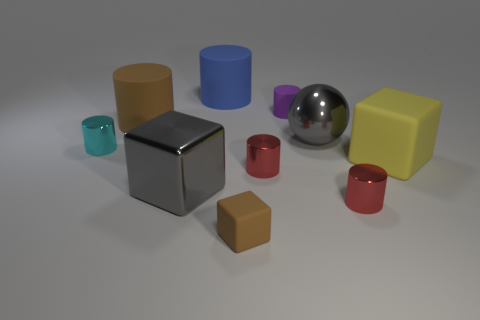How many metal things are tiny cyan things or gray spheres?
Ensure brevity in your answer.  2. Are there any big shiny things behind the gray object that is in front of the yellow object?
Provide a succinct answer. Yes. Is the large thing that is in front of the large yellow object made of the same material as the cyan cylinder?
Offer a terse response. Yes. How many other things are there of the same color as the metal ball?
Give a very brief answer. 1. Is the color of the large ball the same as the large metallic block?
Your answer should be very brief. Yes. What is the size of the red thing on the right side of the big gray metal thing on the right side of the blue object?
Keep it short and to the point. Small. Does the big cube on the left side of the blue matte thing have the same material as the large cylinder in front of the purple cylinder?
Keep it short and to the point. No. There is a big block that is on the left side of the large gray ball; is it the same color as the big ball?
Your answer should be compact. Yes. There is a cyan cylinder; what number of metallic things are in front of it?
Provide a short and direct response. 3. Is the material of the small purple cylinder the same as the brown cube in front of the small cyan metal cylinder?
Your answer should be compact. Yes. 